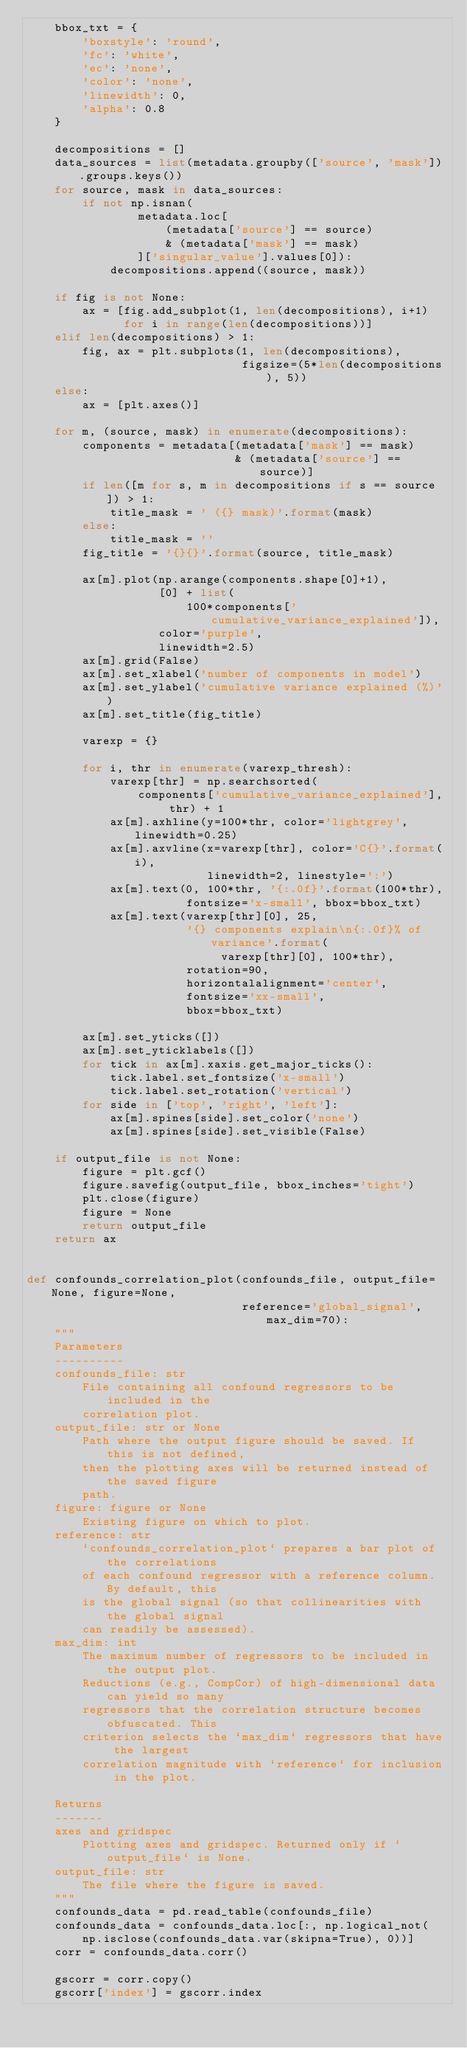Convert code to text. <code><loc_0><loc_0><loc_500><loc_500><_Python_>    bbox_txt = {
        'boxstyle': 'round',
        'fc': 'white',
        'ec': 'none',
        'color': 'none',
        'linewidth': 0,
        'alpha': 0.8
    }

    decompositions = []
    data_sources = list(metadata.groupby(['source', 'mask']).groups.keys())
    for source, mask in data_sources:
        if not np.isnan(
                metadata.loc[
                    (metadata['source'] == source)
                    & (metadata['mask'] == mask)
                ]['singular_value'].values[0]):
            decompositions.append((source, mask))

    if fig is not None:
        ax = [fig.add_subplot(1, len(decompositions), i+1)
              for i in range(len(decompositions))]
    elif len(decompositions) > 1:
        fig, ax = plt.subplots(1, len(decompositions),
                               figsize=(5*len(decompositions), 5))
    else:
        ax = [plt.axes()]

    for m, (source, mask) in enumerate(decompositions):
        components = metadata[(metadata['mask'] == mask)
                              & (metadata['source'] == source)]
        if len([m for s, m in decompositions if s == source]) > 1:
            title_mask = ' ({} mask)'.format(mask)
        else:
            title_mask = ''
        fig_title = '{}{}'.format(source, title_mask)

        ax[m].plot(np.arange(components.shape[0]+1),
                   [0] + list(
                       100*components['cumulative_variance_explained']),
                   color='purple',
                   linewidth=2.5)
        ax[m].grid(False)
        ax[m].set_xlabel('number of components in model')
        ax[m].set_ylabel('cumulative variance explained (%)')
        ax[m].set_title(fig_title)

        varexp = {}

        for i, thr in enumerate(varexp_thresh):
            varexp[thr] = np.searchsorted(
                components['cumulative_variance_explained'], thr) + 1
            ax[m].axhline(y=100*thr, color='lightgrey', linewidth=0.25)
            ax[m].axvline(x=varexp[thr], color='C{}'.format(i),
                          linewidth=2, linestyle=':')
            ax[m].text(0, 100*thr, '{:.0f}'.format(100*thr),
                       fontsize='x-small', bbox=bbox_txt)
            ax[m].text(varexp[thr][0], 25,
                       '{} components explain\n{:.0f}% of variance'.format(
                            varexp[thr][0], 100*thr),
                       rotation=90,
                       horizontalalignment='center',
                       fontsize='xx-small',
                       bbox=bbox_txt)

        ax[m].set_yticks([])
        ax[m].set_yticklabels([])
        for tick in ax[m].xaxis.get_major_ticks():
            tick.label.set_fontsize('x-small')
            tick.label.set_rotation('vertical')
        for side in ['top', 'right', 'left']:
            ax[m].spines[side].set_color('none')
            ax[m].spines[side].set_visible(False)

    if output_file is not None:
        figure = plt.gcf()
        figure.savefig(output_file, bbox_inches='tight')
        plt.close(figure)
        figure = None
        return output_file
    return ax


def confounds_correlation_plot(confounds_file, output_file=None, figure=None,
                               reference='global_signal', max_dim=70):
    """
    Parameters
    ----------
    confounds_file: str
        File containing all confound regressors to be included in the
        correlation plot.
    output_file: str or None
        Path where the output figure should be saved. If this is not defined,
        then the plotting axes will be returned instead of the saved figure
        path.
    figure: figure or None
        Existing figure on which to plot.
    reference: str
        `confounds_correlation_plot` prepares a bar plot of the correlations
        of each confound regressor with a reference column. By default, this
        is the global signal (so that collinearities with the global signal
        can readily be assessed).
    max_dim: int
        The maximum number of regressors to be included in the output plot.
        Reductions (e.g., CompCor) of high-dimensional data can yield so many
        regressors that the correlation structure becomes obfuscated. This
        criterion selects the `max_dim` regressors that have the largest
        correlation magnitude with `reference` for inclusion in the plot.

    Returns
    -------
    axes and gridspec
        Plotting axes and gridspec. Returned only if `output_file` is None.
    output_file: str
        The file where the figure is saved.
    """
    confounds_data = pd.read_table(confounds_file)
    confounds_data = confounds_data.loc[:, np.logical_not(
        np.isclose(confounds_data.var(skipna=True), 0))]
    corr = confounds_data.corr()

    gscorr = corr.copy()
    gscorr['index'] = gscorr.index</code> 